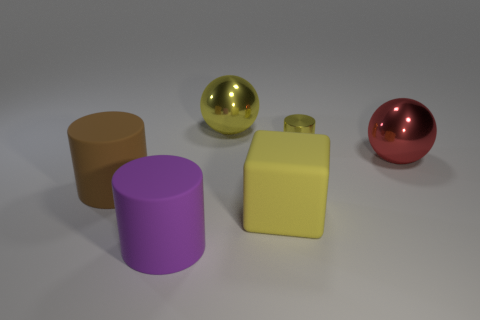Subtract all purple cylinders. How many cylinders are left? 2 Add 2 big blue cylinders. How many objects exist? 8 Subtract all red balls. How many balls are left? 1 Subtract 1 cubes. How many cubes are left? 0 Subtract 0 gray cubes. How many objects are left? 6 Subtract all balls. How many objects are left? 4 Subtract all cyan cylinders. Subtract all purple cubes. How many cylinders are left? 3 Subtract all gray cylinders. How many yellow balls are left? 1 Subtract all big red balls. Subtract all large blue metal cylinders. How many objects are left? 5 Add 3 cubes. How many cubes are left? 4 